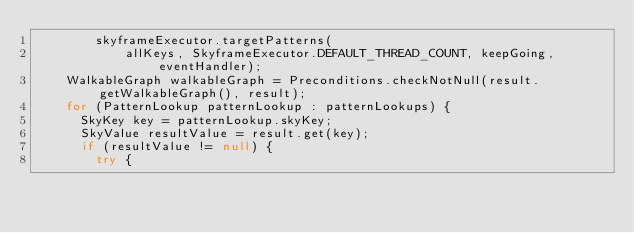Convert code to text. <code><loc_0><loc_0><loc_500><loc_500><_Java_>        skyframeExecutor.targetPatterns(
            allKeys, SkyframeExecutor.DEFAULT_THREAD_COUNT, keepGoing, eventHandler);
    WalkableGraph walkableGraph = Preconditions.checkNotNull(result.getWalkableGraph(), result);
    for (PatternLookup patternLookup : patternLookups) {
      SkyKey key = patternLookup.skyKey;
      SkyValue resultValue = result.get(key);
      if (resultValue != null) {
        try {</code> 